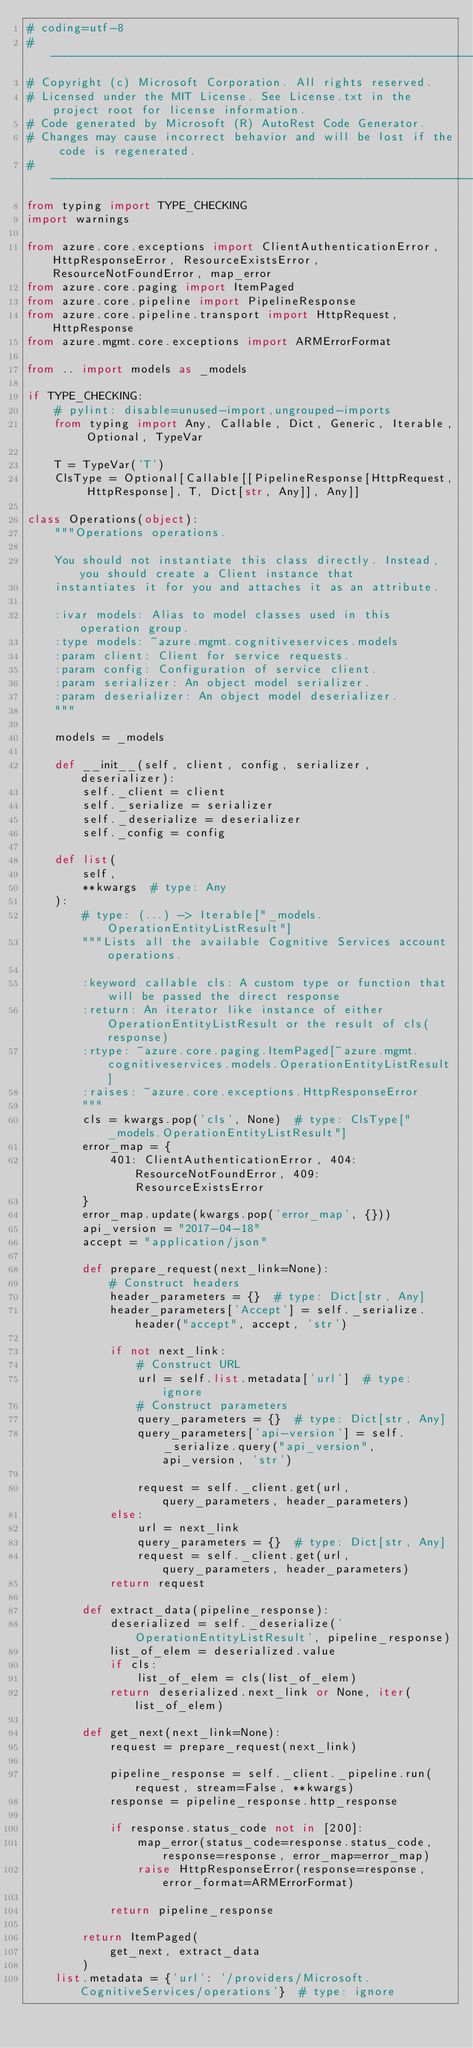Convert code to text. <code><loc_0><loc_0><loc_500><loc_500><_Python_># coding=utf-8
# --------------------------------------------------------------------------
# Copyright (c) Microsoft Corporation. All rights reserved.
# Licensed under the MIT License. See License.txt in the project root for license information.
# Code generated by Microsoft (R) AutoRest Code Generator.
# Changes may cause incorrect behavior and will be lost if the code is regenerated.
# --------------------------------------------------------------------------
from typing import TYPE_CHECKING
import warnings

from azure.core.exceptions import ClientAuthenticationError, HttpResponseError, ResourceExistsError, ResourceNotFoundError, map_error
from azure.core.paging import ItemPaged
from azure.core.pipeline import PipelineResponse
from azure.core.pipeline.transport import HttpRequest, HttpResponse
from azure.mgmt.core.exceptions import ARMErrorFormat

from .. import models as _models

if TYPE_CHECKING:
    # pylint: disable=unused-import,ungrouped-imports
    from typing import Any, Callable, Dict, Generic, Iterable, Optional, TypeVar

    T = TypeVar('T')
    ClsType = Optional[Callable[[PipelineResponse[HttpRequest, HttpResponse], T, Dict[str, Any]], Any]]

class Operations(object):
    """Operations operations.

    You should not instantiate this class directly. Instead, you should create a Client instance that
    instantiates it for you and attaches it as an attribute.

    :ivar models: Alias to model classes used in this operation group.
    :type models: ~azure.mgmt.cognitiveservices.models
    :param client: Client for service requests.
    :param config: Configuration of service client.
    :param serializer: An object model serializer.
    :param deserializer: An object model deserializer.
    """

    models = _models

    def __init__(self, client, config, serializer, deserializer):
        self._client = client
        self._serialize = serializer
        self._deserialize = deserializer
        self._config = config

    def list(
        self,
        **kwargs  # type: Any
    ):
        # type: (...) -> Iterable["_models.OperationEntityListResult"]
        """Lists all the available Cognitive Services account operations.

        :keyword callable cls: A custom type or function that will be passed the direct response
        :return: An iterator like instance of either OperationEntityListResult or the result of cls(response)
        :rtype: ~azure.core.paging.ItemPaged[~azure.mgmt.cognitiveservices.models.OperationEntityListResult]
        :raises: ~azure.core.exceptions.HttpResponseError
        """
        cls = kwargs.pop('cls', None)  # type: ClsType["_models.OperationEntityListResult"]
        error_map = {
            401: ClientAuthenticationError, 404: ResourceNotFoundError, 409: ResourceExistsError
        }
        error_map.update(kwargs.pop('error_map', {}))
        api_version = "2017-04-18"
        accept = "application/json"

        def prepare_request(next_link=None):
            # Construct headers
            header_parameters = {}  # type: Dict[str, Any]
            header_parameters['Accept'] = self._serialize.header("accept", accept, 'str')

            if not next_link:
                # Construct URL
                url = self.list.metadata['url']  # type: ignore
                # Construct parameters
                query_parameters = {}  # type: Dict[str, Any]
                query_parameters['api-version'] = self._serialize.query("api_version", api_version, 'str')

                request = self._client.get(url, query_parameters, header_parameters)
            else:
                url = next_link
                query_parameters = {}  # type: Dict[str, Any]
                request = self._client.get(url, query_parameters, header_parameters)
            return request

        def extract_data(pipeline_response):
            deserialized = self._deserialize('OperationEntityListResult', pipeline_response)
            list_of_elem = deserialized.value
            if cls:
                list_of_elem = cls(list_of_elem)
            return deserialized.next_link or None, iter(list_of_elem)

        def get_next(next_link=None):
            request = prepare_request(next_link)

            pipeline_response = self._client._pipeline.run(request, stream=False, **kwargs)
            response = pipeline_response.http_response

            if response.status_code not in [200]:
                map_error(status_code=response.status_code, response=response, error_map=error_map)
                raise HttpResponseError(response=response, error_format=ARMErrorFormat)

            return pipeline_response

        return ItemPaged(
            get_next, extract_data
        )
    list.metadata = {'url': '/providers/Microsoft.CognitiveServices/operations'}  # type: ignore
</code> 